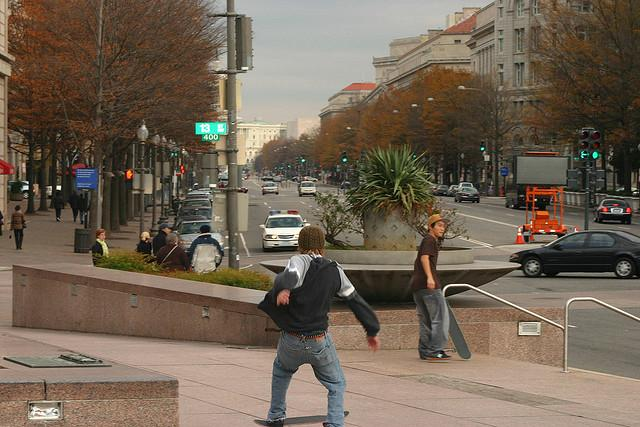Why plants are planted on roadside? decoration 